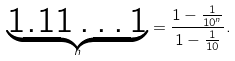<formula> <loc_0><loc_0><loc_500><loc_500>\underset { n } { \underbrace { 1 . 1 1 \dots 1 } } = \frac { 1 - \frac { 1 } { 1 0 ^ { n } } } { 1 - \frac { 1 } { 1 0 } } .</formula> 